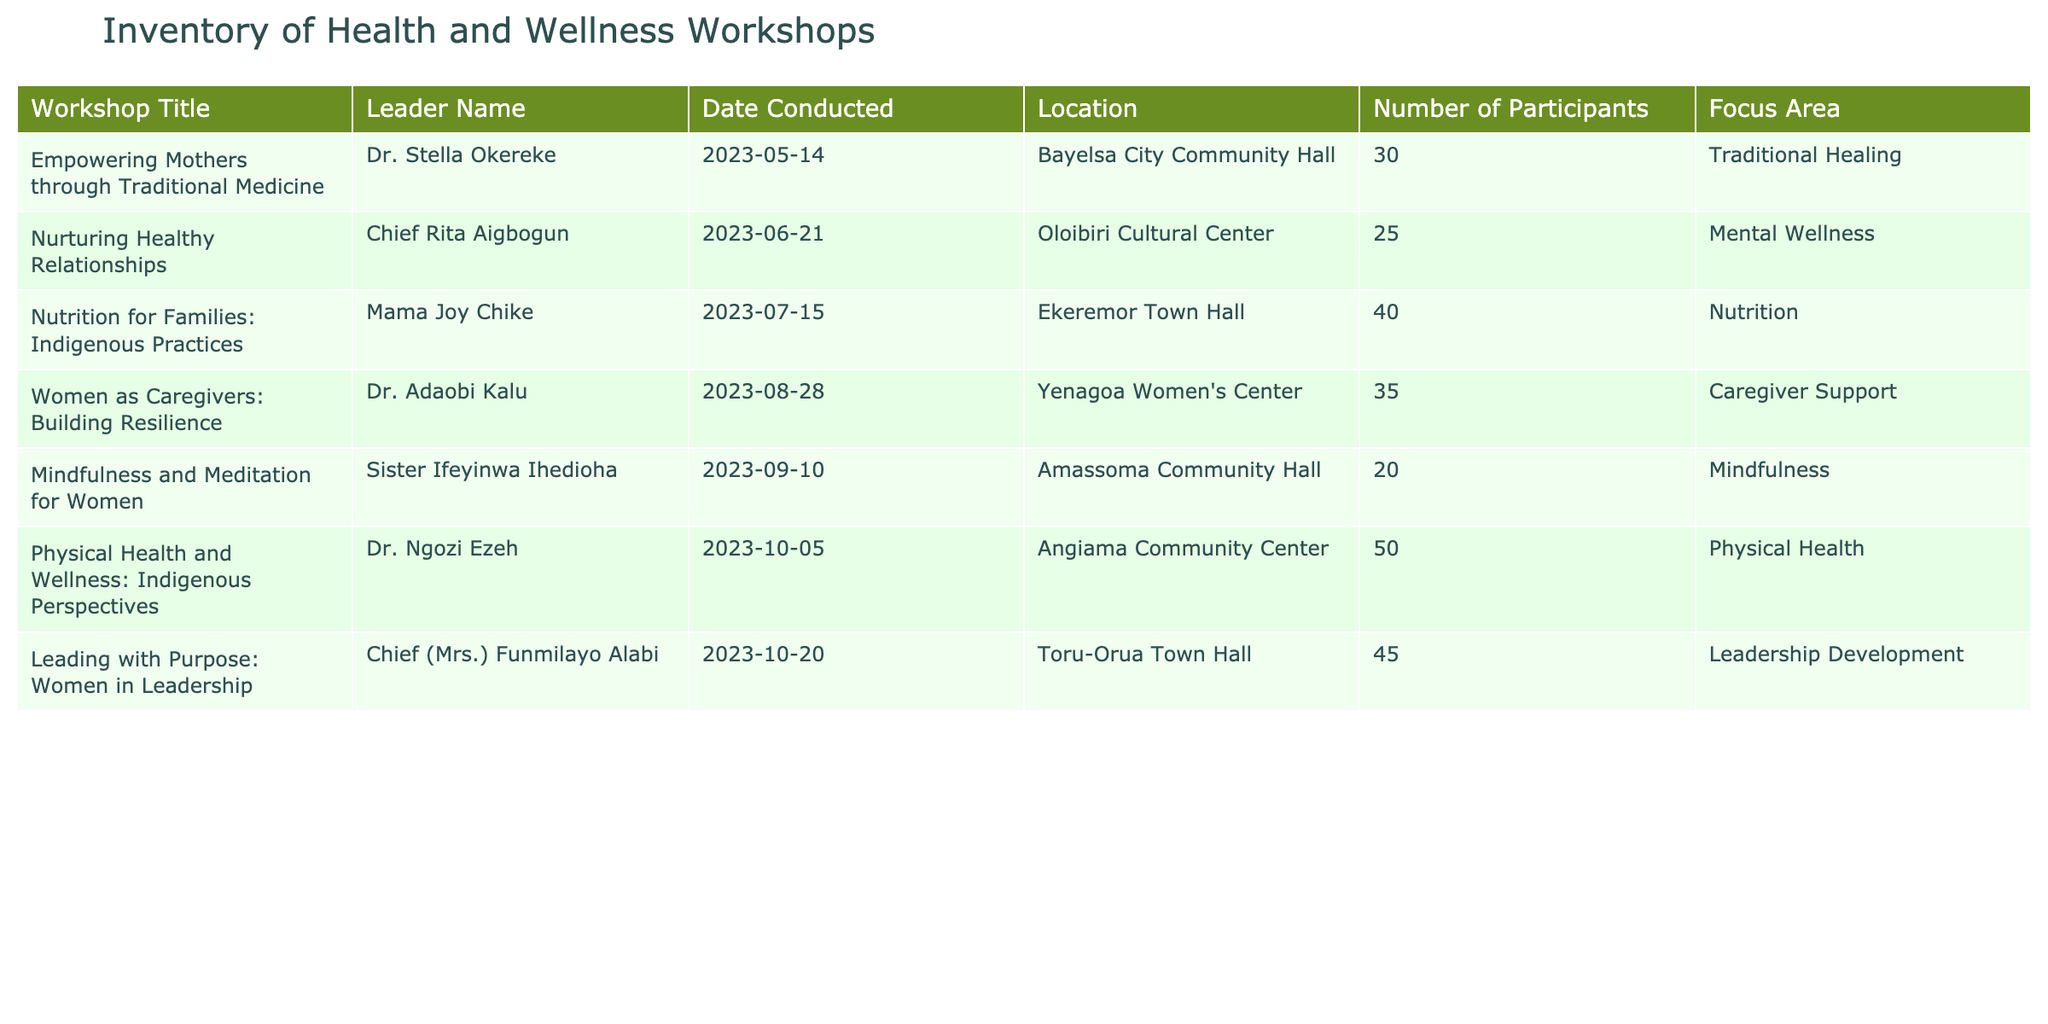What was the title of the workshop conducted by Dr. Stella Okereke? The title of the workshop is listed in the first row under "Workshop Title." It indicates that Dr. Stella Okereke conducted a workshop titled "Empowering Mothers through Traditional Medicine."
Answer: Empowering Mothers through Traditional Medicine How many participants attended the "Nutrition for Families: Indigenous Practices" workshop? Looking at the corresponding row for the "Nutrition for Families: Indigenous Practices" workshop, the "Number of Participants" column shows that 40 participants attended the workshop.
Answer: 40 Which workshop focused on leadership development and when was it conducted? By examining the table, we find that the workshop titled "Leading with Purpose: Women in Leadership" is associated with "Leadership Development." It was conducted on "2023-10-20."
Answer: Leading with Purpose: Women in Leadership, 2023-10-20 What is the total number of participants across all workshops? To find the total, we add the number of participants from each workshop: 30 + 25 + 40 + 35 + 20 + 50 + 45 = 245 participants. Thus, the total number of participants across all workshops is 245.
Answer: 245 Was there a workshop that had 20 or fewer participants? By checking the "Number of Participants" column, the "Mindfulness and Meditation for Women" workshop is found to have only 20 participants, confirming that there is indeed such a workshop.
Answer: Yes Which workshop had the highest number of participants and what was that number? By scanning the "Number of Participants" column, we see that "Physical Health and Wellness: Indigenous Perspectives" workshop had the highest number of participants, totaling 50.
Answer: Physical Health and Wellness: Indigenous Perspectives, 50 How many workshops were conducted in July and what were their titles? By reviewing the table, there is only one workshop conducted in July, which is "Nutrition for Families: Indigenous Practices." Therefore, the count is 1 and the title is "Nutrition for Families: Indigenous Practices."
Answer: 1, Nutrition for Families: Indigenous Practices Did any workshop focus on mental wellness? The "Focus Area" column is examined, and it shows that the workshop titled "Nurturing Healthy Relationships" specifically stated "Mental Wellness" as its focus area, meaning there was indeed a workshop on this topic.
Answer: Yes What was the average number of participants for all the workshops conducted? To calculate the average, we first sum the total number of participants (245) and divide it by the total number of workshops (7), resulting in an average of 34.86 participants, which can be rounded to 35.
Answer: 35 